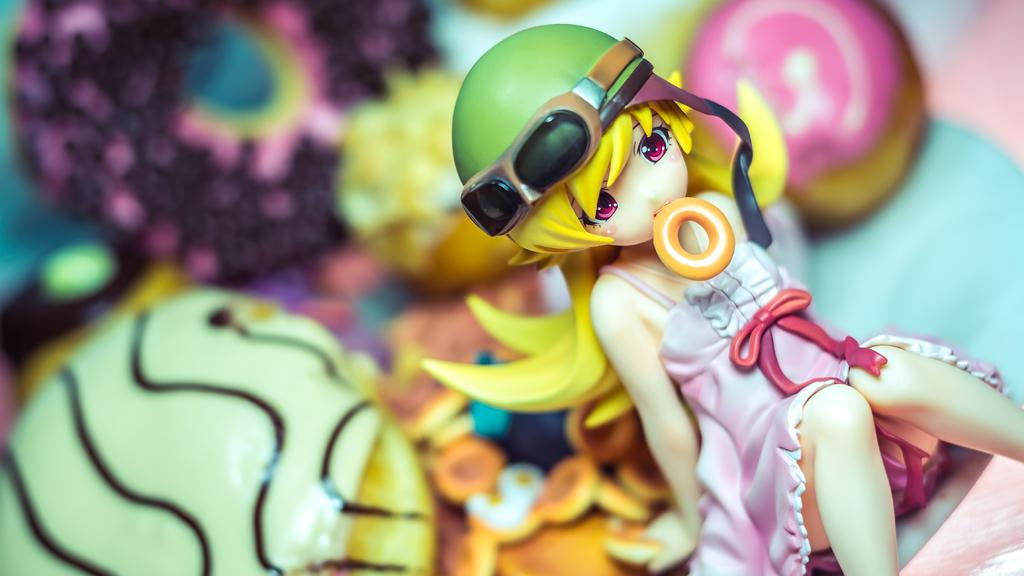What is the main subject of the image? There is a doll in the image. Can you describe the background of the doll? The background of the doll is blurred. How much debt does the doll have in the image? There is no indication of debt in the image, as it features a doll with a blurred background. Is there a flock of birds visible in the image? There are no birds or flocks present in the image; it features a doll with a blurred background. 